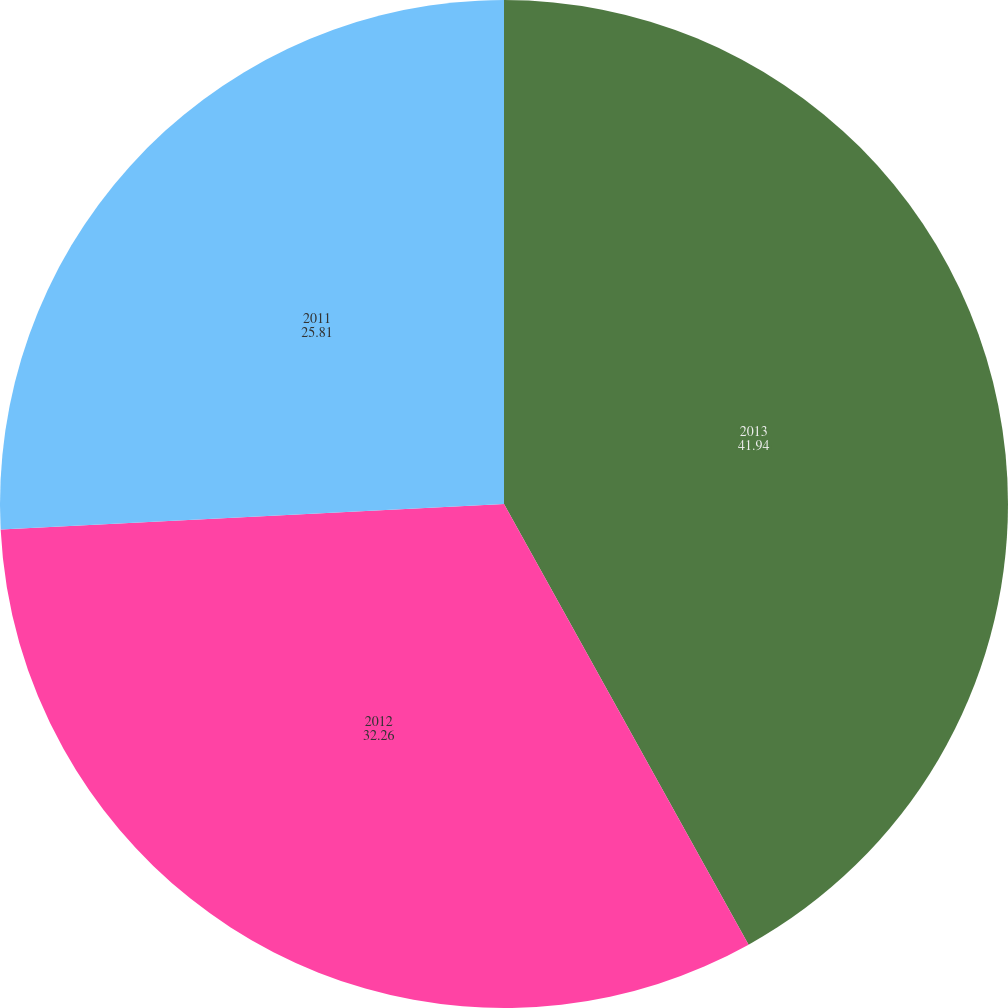<chart> <loc_0><loc_0><loc_500><loc_500><pie_chart><fcel>2013<fcel>2012<fcel>2011<nl><fcel>41.94%<fcel>32.26%<fcel>25.81%<nl></chart> 